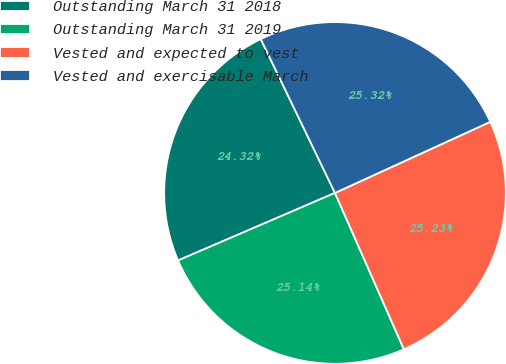Convert chart to OTSL. <chart><loc_0><loc_0><loc_500><loc_500><pie_chart><fcel>Outstanding March 31 2018<fcel>Outstanding March 31 2019<fcel>Vested and expected to vest<fcel>Vested and exercisable March<nl><fcel>24.32%<fcel>25.14%<fcel>25.23%<fcel>25.32%<nl></chart> 